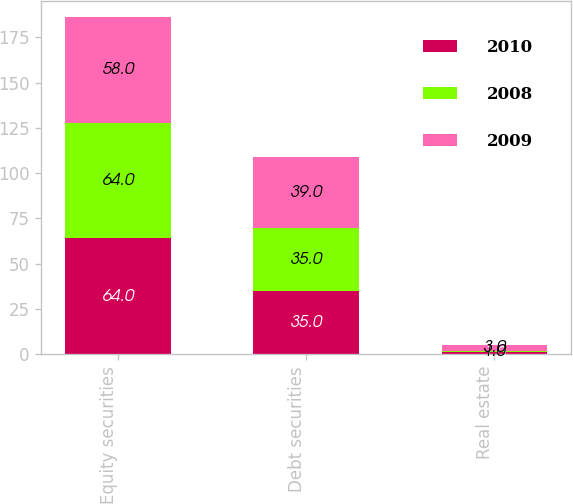Convert chart. <chart><loc_0><loc_0><loc_500><loc_500><stacked_bar_chart><ecel><fcel>Equity securities<fcel>Debt securities<fcel>Real estate<nl><fcel>2010<fcel>64<fcel>35<fcel>1<nl><fcel>2008<fcel>64<fcel>35<fcel>1<nl><fcel>2009<fcel>58<fcel>39<fcel>3<nl></chart> 